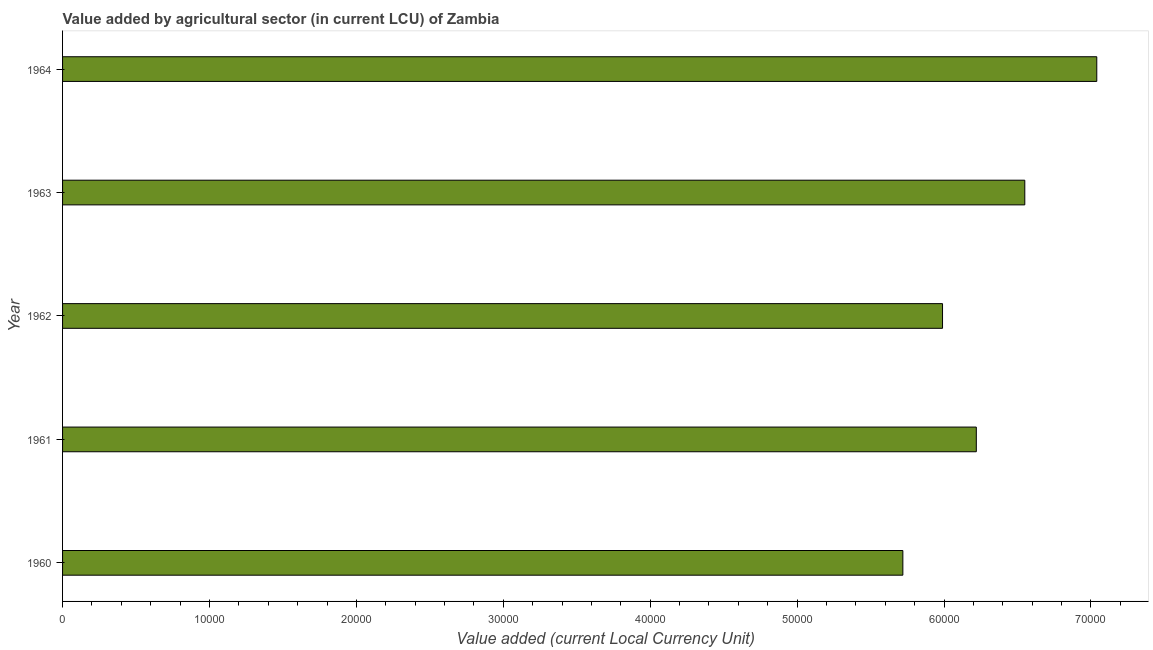What is the title of the graph?
Provide a succinct answer. Value added by agricultural sector (in current LCU) of Zambia. What is the label or title of the X-axis?
Offer a terse response. Value added (current Local Currency Unit). What is the label or title of the Y-axis?
Your answer should be compact. Year. What is the value added by agriculture sector in 1964?
Provide a short and direct response. 7.04e+04. Across all years, what is the maximum value added by agriculture sector?
Offer a very short reply. 7.04e+04. Across all years, what is the minimum value added by agriculture sector?
Provide a short and direct response. 5.72e+04. In which year was the value added by agriculture sector maximum?
Your response must be concise. 1964. What is the sum of the value added by agriculture sector?
Your answer should be compact. 3.15e+05. What is the difference between the value added by agriculture sector in 1960 and 1961?
Your response must be concise. -5000. What is the average value added by agriculture sector per year?
Provide a short and direct response. 6.30e+04. What is the median value added by agriculture sector?
Offer a very short reply. 6.22e+04. What is the ratio of the value added by agriculture sector in 1962 to that in 1963?
Provide a succinct answer. 0.92. What is the difference between the highest and the second highest value added by agriculture sector?
Your answer should be compact. 4900. Is the sum of the value added by agriculture sector in 1962 and 1963 greater than the maximum value added by agriculture sector across all years?
Offer a very short reply. Yes. What is the difference between the highest and the lowest value added by agriculture sector?
Offer a terse response. 1.32e+04. How many bars are there?
Your answer should be very brief. 5. Are all the bars in the graph horizontal?
Provide a short and direct response. Yes. How many years are there in the graph?
Make the answer very short. 5. What is the Value added (current Local Currency Unit) in 1960?
Provide a short and direct response. 5.72e+04. What is the Value added (current Local Currency Unit) of 1961?
Make the answer very short. 6.22e+04. What is the Value added (current Local Currency Unit) of 1962?
Offer a terse response. 5.99e+04. What is the Value added (current Local Currency Unit) of 1963?
Provide a short and direct response. 6.55e+04. What is the Value added (current Local Currency Unit) in 1964?
Provide a succinct answer. 7.04e+04. What is the difference between the Value added (current Local Currency Unit) in 1960 and 1961?
Your answer should be compact. -5000. What is the difference between the Value added (current Local Currency Unit) in 1960 and 1962?
Offer a very short reply. -2700. What is the difference between the Value added (current Local Currency Unit) in 1960 and 1963?
Your answer should be compact. -8300. What is the difference between the Value added (current Local Currency Unit) in 1960 and 1964?
Ensure brevity in your answer.  -1.32e+04. What is the difference between the Value added (current Local Currency Unit) in 1961 and 1962?
Ensure brevity in your answer.  2300. What is the difference between the Value added (current Local Currency Unit) in 1961 and 1963?
Provide a short and direct response. -3300. What is the difference between the Value added (current Local Currency Unit) in 1961 and 1964?
Keep it short and to the point. -8200. What is the difference between the Value added (current Local Currency Unit) in 1962 and 1963?
Provide a short and direct response. -5600. What is the difference between the Value added (current Local Currency Unit) in 1962 and 1964?
Your answer should be very brief. -1.05e+04. What is the difference between the Value added (current Local Currency Unit) in 1963 and 1964?
Give a very brief answer. -4900. What is the ratio of the Value added (current Local Currency Unit) in 1960 to that in 1961?
Provide a short and direct response. 0.92. What is the ratio of the Value added (current Local Currency Unit) in 1960 to that in 1962?
Keep it short and to the point. 0.95. What is the ratio of the Value added (current Local Currency Unit) in 1960 to that in 1963?
Provide a short and direct response. 0.87. What is the ratio of the Value added (current Local Currency Unit) in 1960 to that in 1964?
Provide a succinct answer. 0.81. What is the ratio of the Value added (current Local Currency Unit) in 1961 to that in 1962?
Your response must be concise. 1.04. What is the ratio of the Value added (current Local Currency Unit) in 1961 to that in 1964?
Provide a short and direct response. 0.88. What is the ratio of the Value added (current Local Currency Unit) in 1962 to that in 1963?
Offer a terse response. 0.92. What is the ratio of the Value added (current Local Currency Unit) in 1962 to that in 1964?
Provide a succinct answer. 0.85. What is the ratio of the Value added (current Local Currency Unit) in 1963 to that in 1964?
Provide a succinct answer. 0.93. 